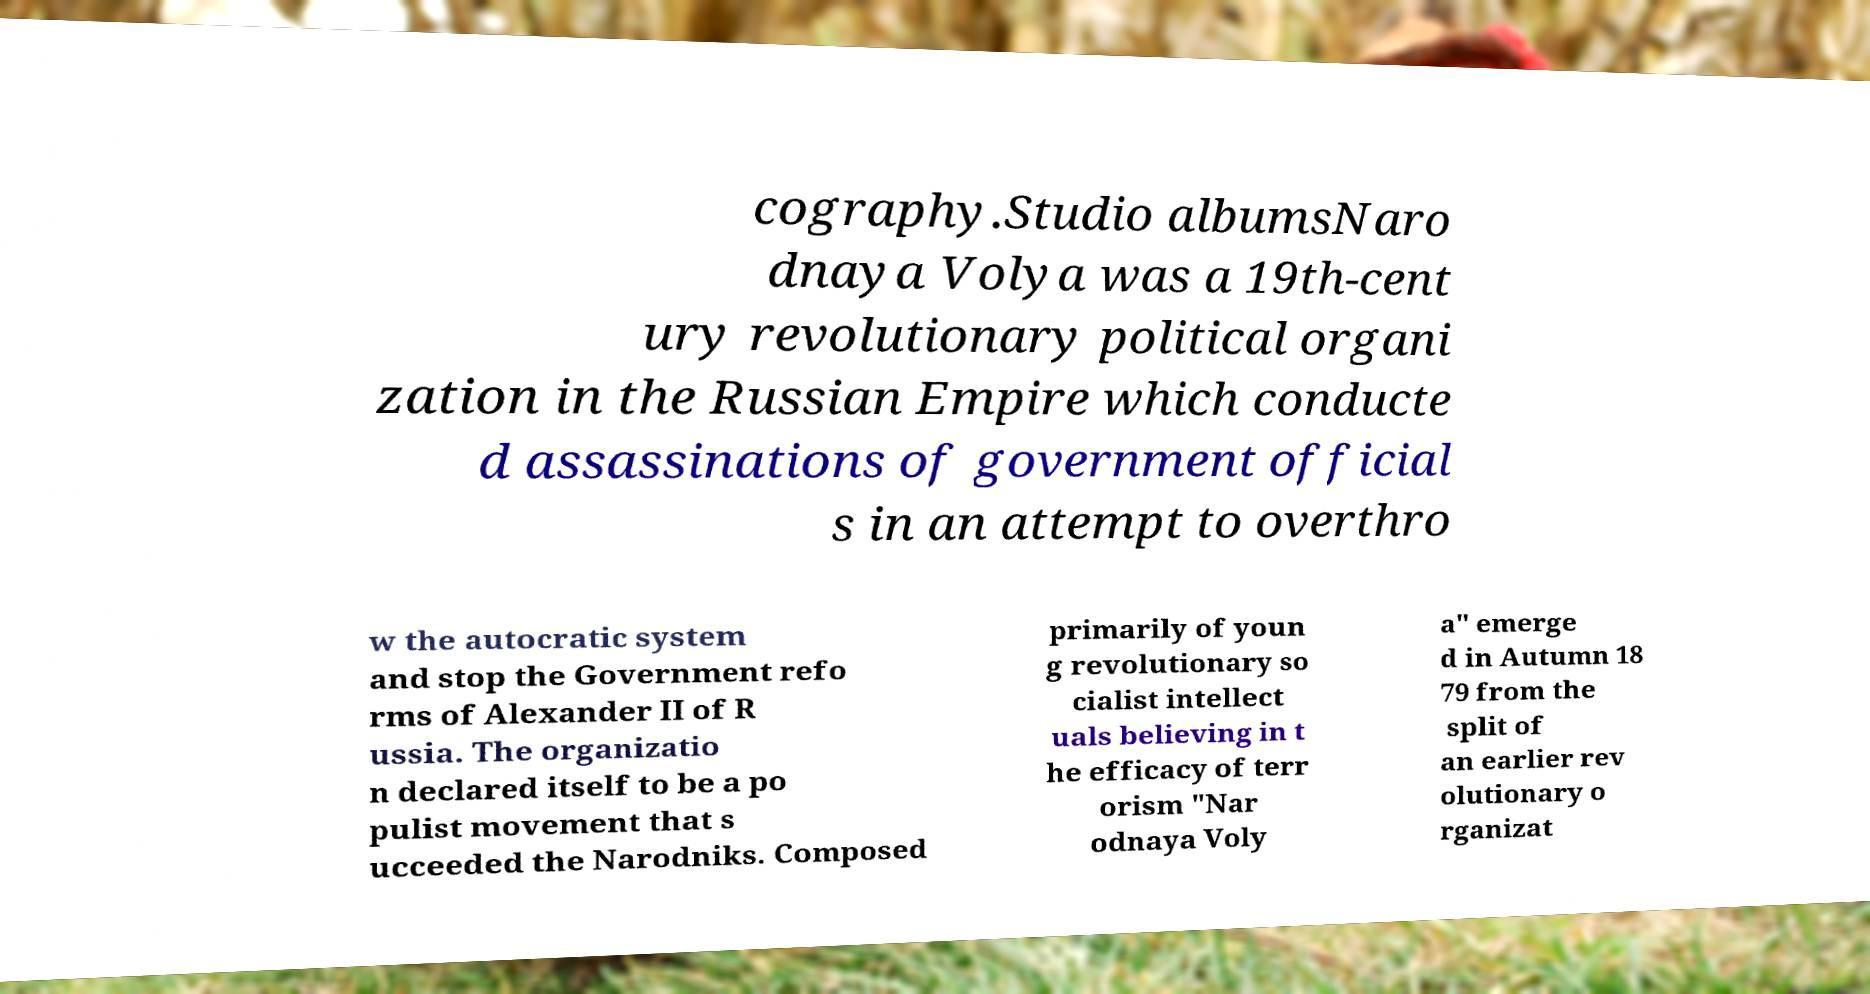Can you accurately transcribe the text from the provided image for me? cography.Studio albumsNaro dnaya Volya was a 19th-cent ury revolutionary political organi zation in the Russian Empire which conducte d assassinations of government official s in an attempt to overthro w the autocratic system and stop the Government refo rms of Alexander II of R ussia. The organizatio n declared itself to be a po pulist movement that s ucceeded the Narodniks. Composed primarily of youn g revolutionary so cialist intellect uals believing in t he efficacy of terr orism "Nar odnaya Voly a" emerge d in Autumn 18 79 from the split of an earlier rev olutionary o rganizat 